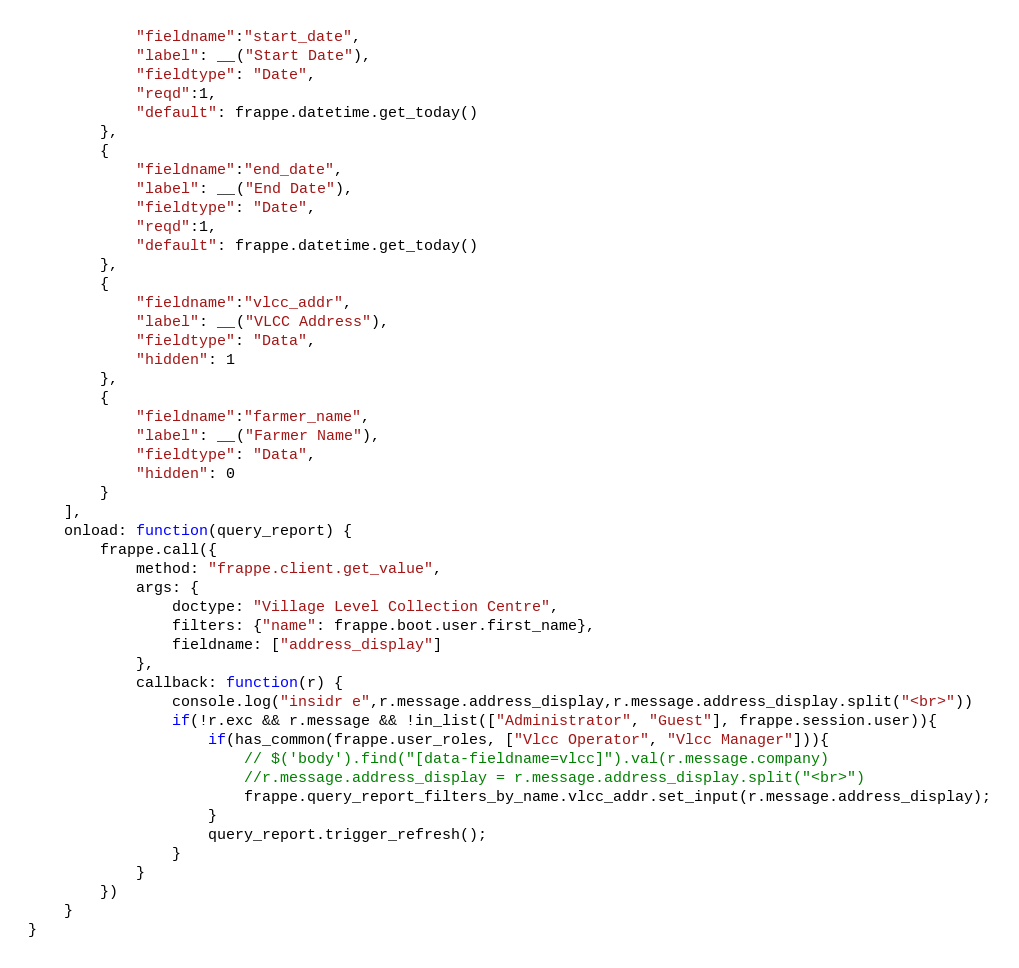Convert code to text. <code><loc_0><loc_0><loc_500><loc_500><_JavaScript_>			"fieldname":"start_date",
			"label": __("Start Date"),
			"fieldtype": "Date",
			"reqd":1,
			"default": frappe.datetime.get_today()
		},
		{
			"fieldname":"end_date",
			"label": __("End Date"),
			"fieldtype": "Date",
			"reqd":1,
			"default": frappe.datetime.get_today()
		},
		{
			"fieldname":"vlcc_addr",
			"label": __("VLCC Address"),
			"fieldtype": "Data",
			"hidden": 1
		},
		{
			"fieldname":"farmer_name",
			"label": __("Farmer Name"),
			"fieldtype": "Data",
			"hidden": 0
		}	
	],
	onload: function(query_report) {
		frappe.call({
			method: "frappe.client.get_value",
			args: {
				doctype: "Village Level Collection Centre",
				filters: {"name": frappe.boot.user.first_name},
				fieldname: ["address_display"]
			},
			callback: function(r) {
				console.log("insidr e",r.message.address_display,r.message.address_display.split("<br>"))
				if(!r.exc && r.message && !in_list(["Administrator", "Guest"], frappe.session.user)){
					if(has_common(frappe.user_roles, ["Vlcc Operator", "Vlcc Manager"])){
						// $('body').find("[data-fieldname=vlcc]").val(r.message.company)
						//r.message.address_display = r.message.address_display.split("<br>")
						frappe.query_report_filters_by_name.vlcc_addr.set_input(r.message.address_display);
					}
					query_report.trigger_refresh();
				}
			}
		})
	}
}
</code> 